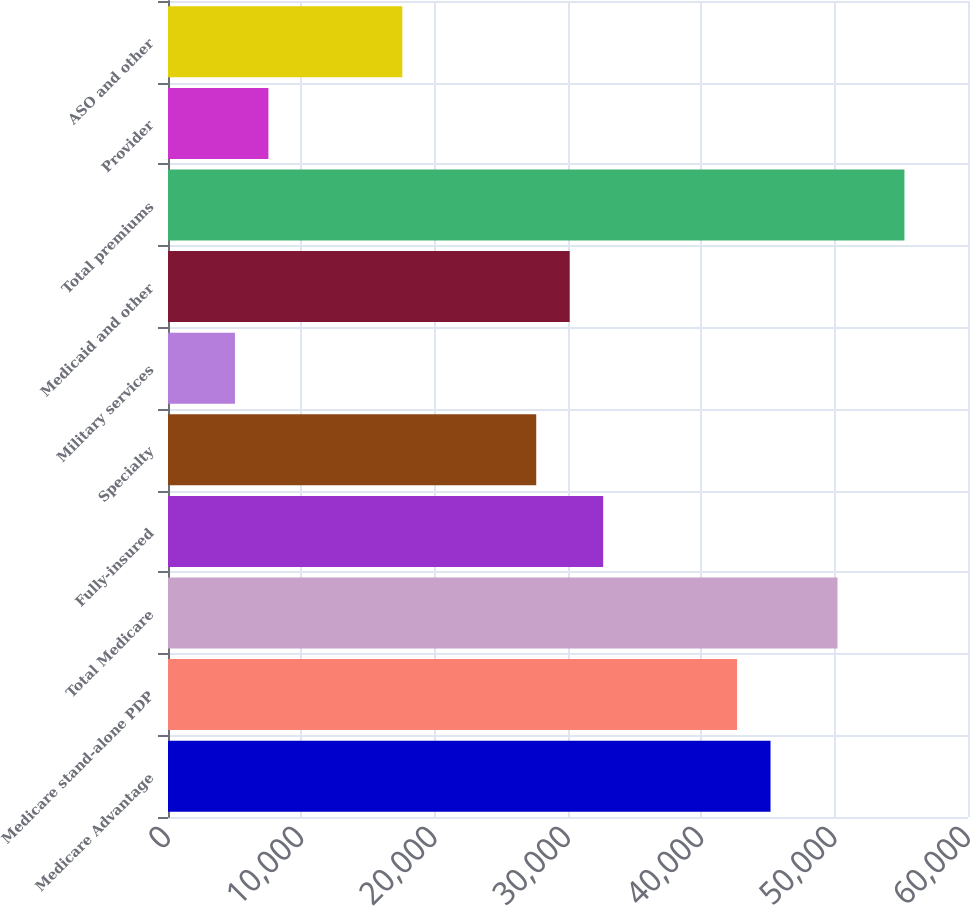<chart> <loc_0><loc_0><loc_500><loc_500><bar_chart><fcel>Medicare Advantage<fcel>Medicare stand-alone PDP<fcel>Total Medicare<fcel>Fully-insured<fcel>Specialty<fcel>Military services<fcel>Medicaid and other<fcel>Total premiums<fcel>Provider<fcel>ASO and other<nl><fcel>45190.6<fcel>42680<fcel>50211.8<fcel>32637.7<fcel>27616.5<fcel>5021.33<fcel>30127.1<fcel>55232.9<fcel>7531.91<fcel>17574.2<nl></chart> 